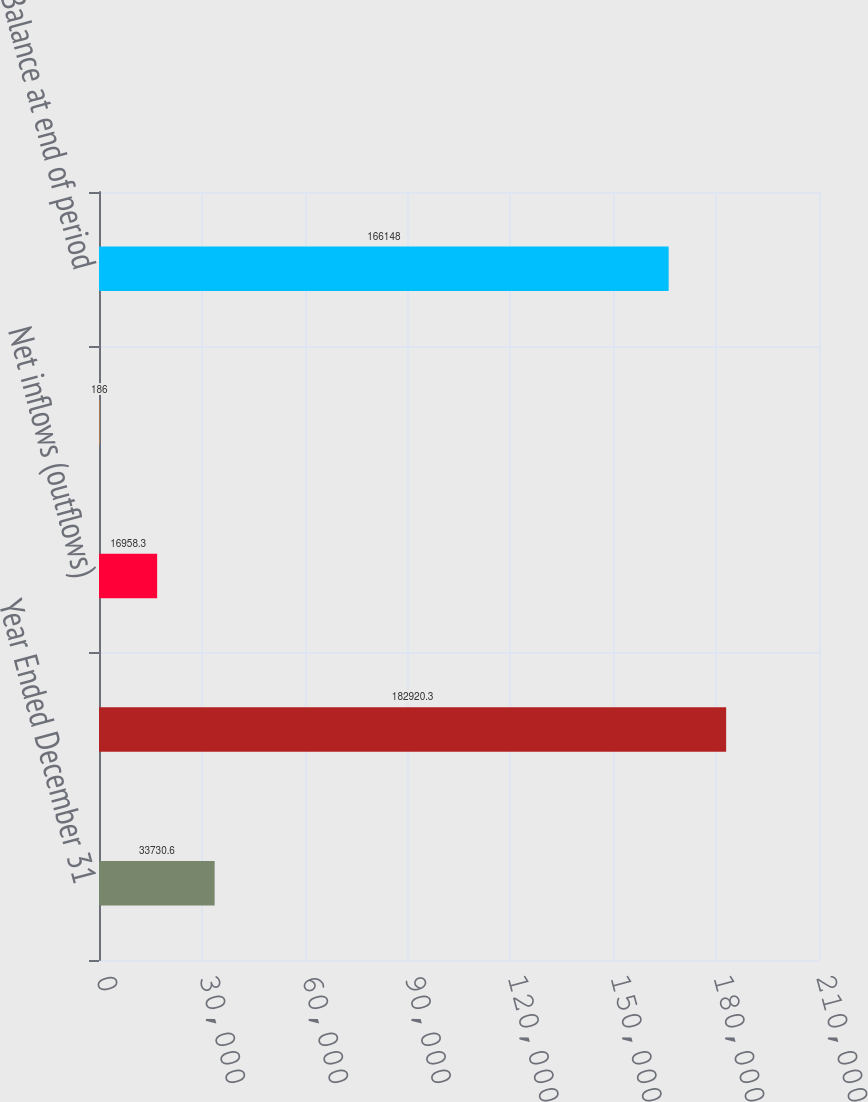Convert chart. <chart><loc_0><loc_0><loc_500><loc_500><bar_chart><fcel>Year Ended December 31<fcel>Balance at beginning of period<fcel>Net inflows (outflows)<fcel>Net market gains (losses) and<fcel>Balance at end of period<nl><fcel>33730.6<fcel>182920<fcel>16958.3<fcel>186<fcel>166148<nl></chart> 